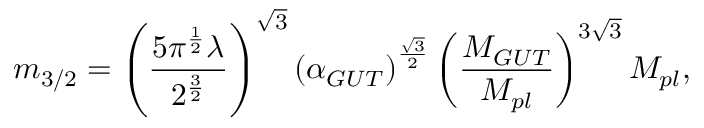Convert formula to latex. <formula><loc_0><loc_0><loc_500><loc_500>m _ { 3 / 2 } = \left ( \frac { 5 \pi ^ { \frac { 1 } { 2 } } \lambda } { 2 ^ { \frac { 3 } { 2 } } } \right ) ^ { \sqrt { 3 } } \left ( \alpha _ { G U T } \right ) ^ { \frac { \sqrt { 3 } } { 2 } } \left ( \frac { M _ { G U T } } { M _ { p l } } \right ) ^ { 3 \sqrt { 3 } } M _ { p l } ,</formula> 